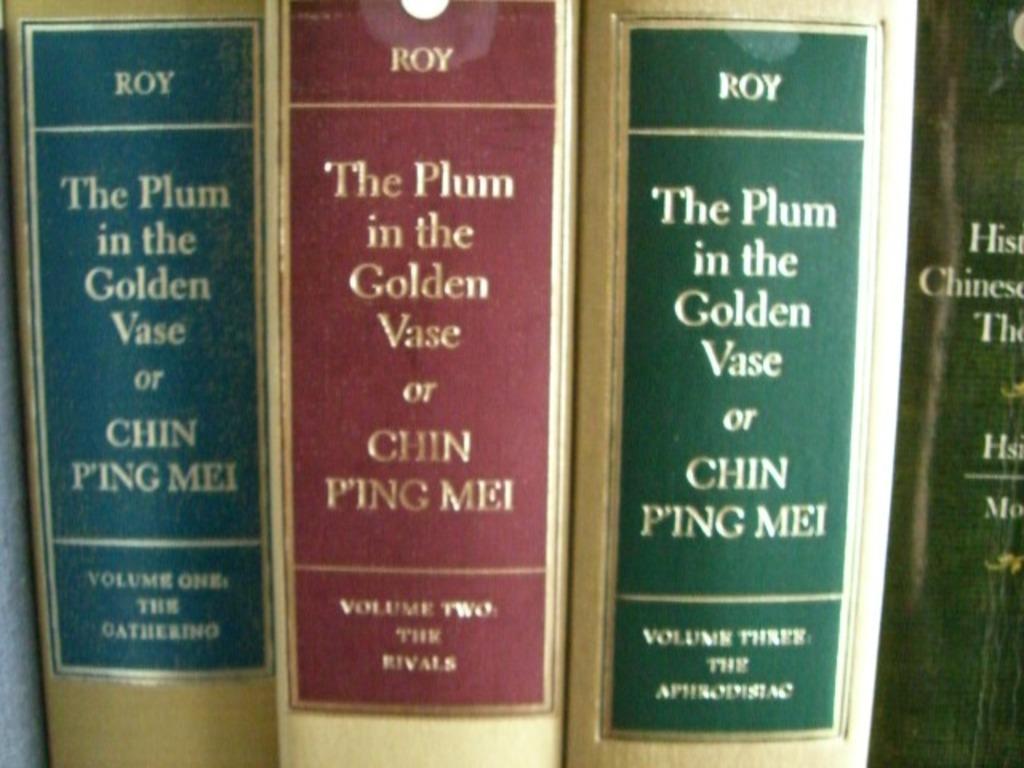How many different volumes is the plum in the golden vase split into?
Offer a terse response. 3. Who wrote these volumes?
Your answer should be very brief. Chin ping mei. 